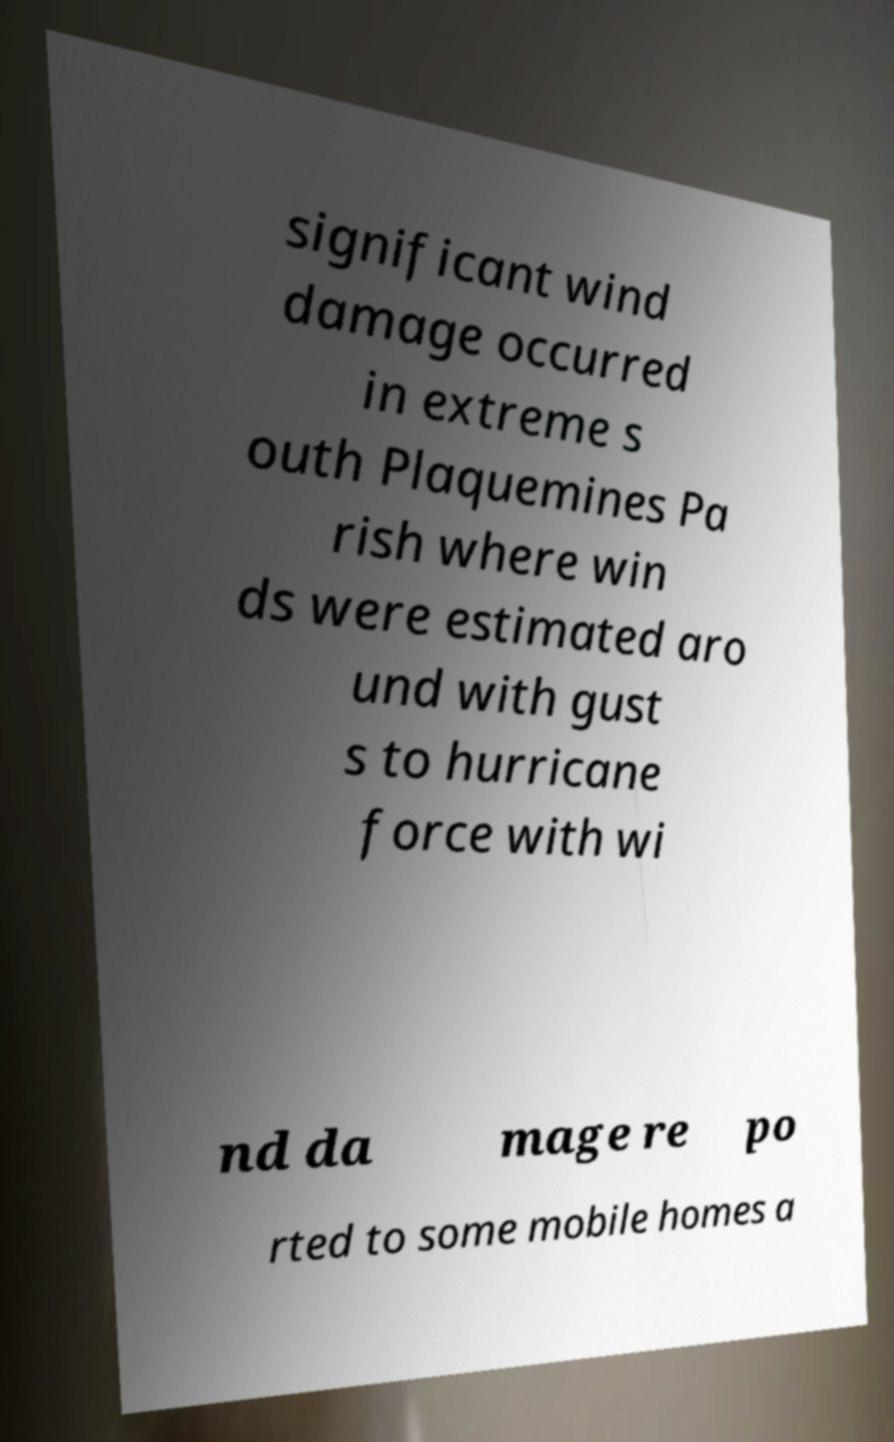I need the written content from this picture converted into text. Can you do that? significant wind damage occurred in extreme s outh Plaquemines Pa rish where win ds were estimated aro und with gust s to hurricane force with wi nd da mage re po rted to some mobile homes a 